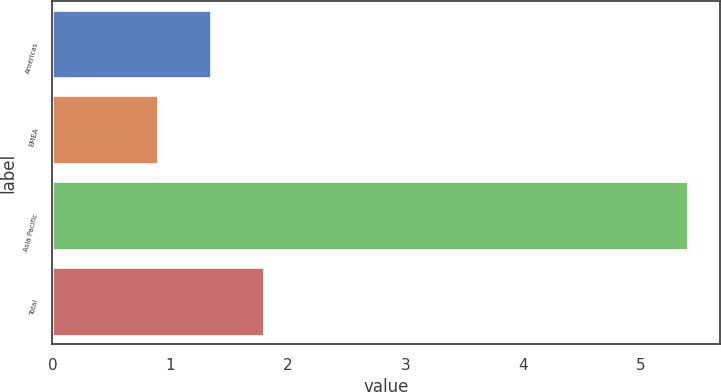Convert chart to OTSL. <chart><loc_0><loc_0><loc_500><loc_500><bar_chart><fcel>Americas<fcel>EMEA<fcel>Asia Pacific<fcel>Total<nl><fcel>1.35<fcel>0.9<fcel>5.4<fcel>1.8<nl></chart> 